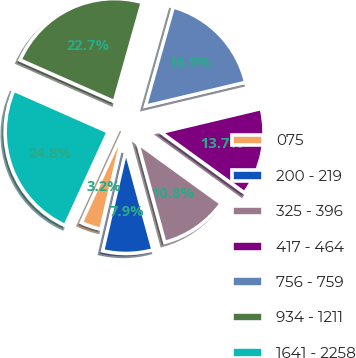<chart> <loc_0><loc_0><loc_500><loc_500><pie_chart><fcel>075<fcel>200 - 219<fcel>325 - 396<fcel>417 - 464<fcel>756 - 759<fcel>934 - 1211<fcel>1641 - 2258<nl><fcel>3.21%<fcel>7.87%<fcel>10.79%<fcel>13.7%<fcel>16.91%<fcel>22.74%<fcel>24.78%<nl></chart> 